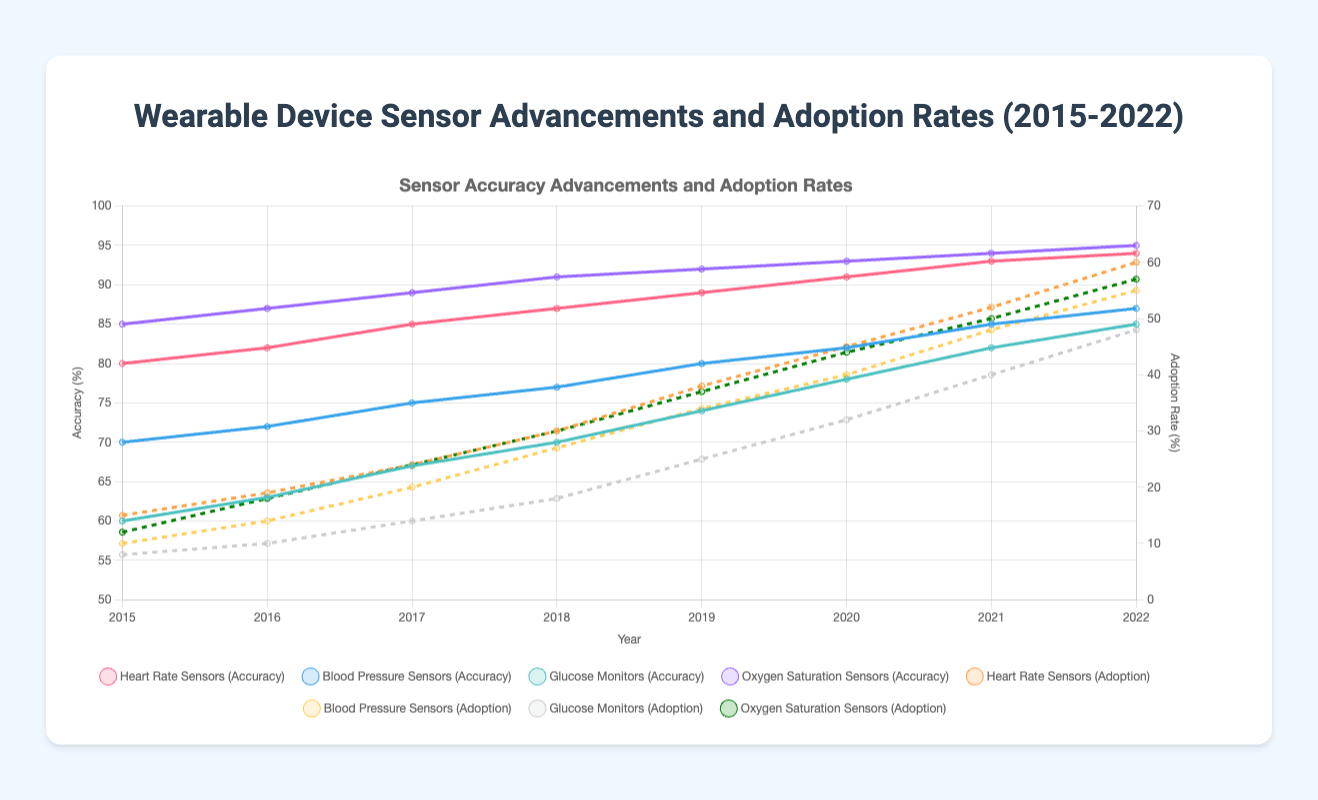what trend do we observe for heart rate sensor accuracy over the years? From 2015 to 2022, heart rate sensor accuracy consistently increases from 80% to 94%.
Answer: increased how much did the adoption rate of glucose monitors increase between 2019 and 2020? In 2019, the adoption rate was 25%, and it increased to 32% in 2020. The difference is 32% - 25% = 7%.
Answer: 7% what is the average accuracy of oxygen saturation sensors between 2015 and 2018? The accuracies of oxygen saturation sensors from 2015 to 2018 are 85%, 87%, 89%, and 91%. The average accuracy is (85 + 87 + 89 + 91) / 4 = 88%.
Answer: 88% did the adoption rate of blood pressure sensors ever exceed the adoption rate of oxygen saturation sensors? Yes, in 2020, the adoption rate of blood pressure sensors was 40%, while that for oxygen saturation sensors was 37%.
Answer: yes which sensor showed the greatest improvement in accuracy from 2015 to 2022? The glucose monitors improved from 60% in 2015 to 85% in 2022, an increase of 25 percentage points. No other sensor shows a larger improvement.
Answer: glucose monitors how do the average adoption rates of heart rate sensors and blood pressure sensors compare over the 8-year period? The average adoption rate for heart rate sensors is (15 + 19 + 24 + 30 + 38 + 45 + 52 + 60) / 8 = 35.38%. The average for blood pressure sensors is (10 + 14 + 20 + 27 + 34 + 40 + 48 + 55) / 8 = 31%. Heart rate sensors have a higher average adoption rate.
Answer: heart rate sensors what year had the smallest difference between the adoption rates of glucose monitors and oxygen saturation sensors? In 2019, the adoption rates were 25% for glucose monitors and 37% for oxygen saturation sensors, giving a difference of 12 percentage points. This is the smallest difference compared to other years.
Answer: 2019 which sensor had the highest adoption rate in 2022? In 2022, heart rate sensors had the highest adoption rate with 60%.
Answer: heart rate sensors 